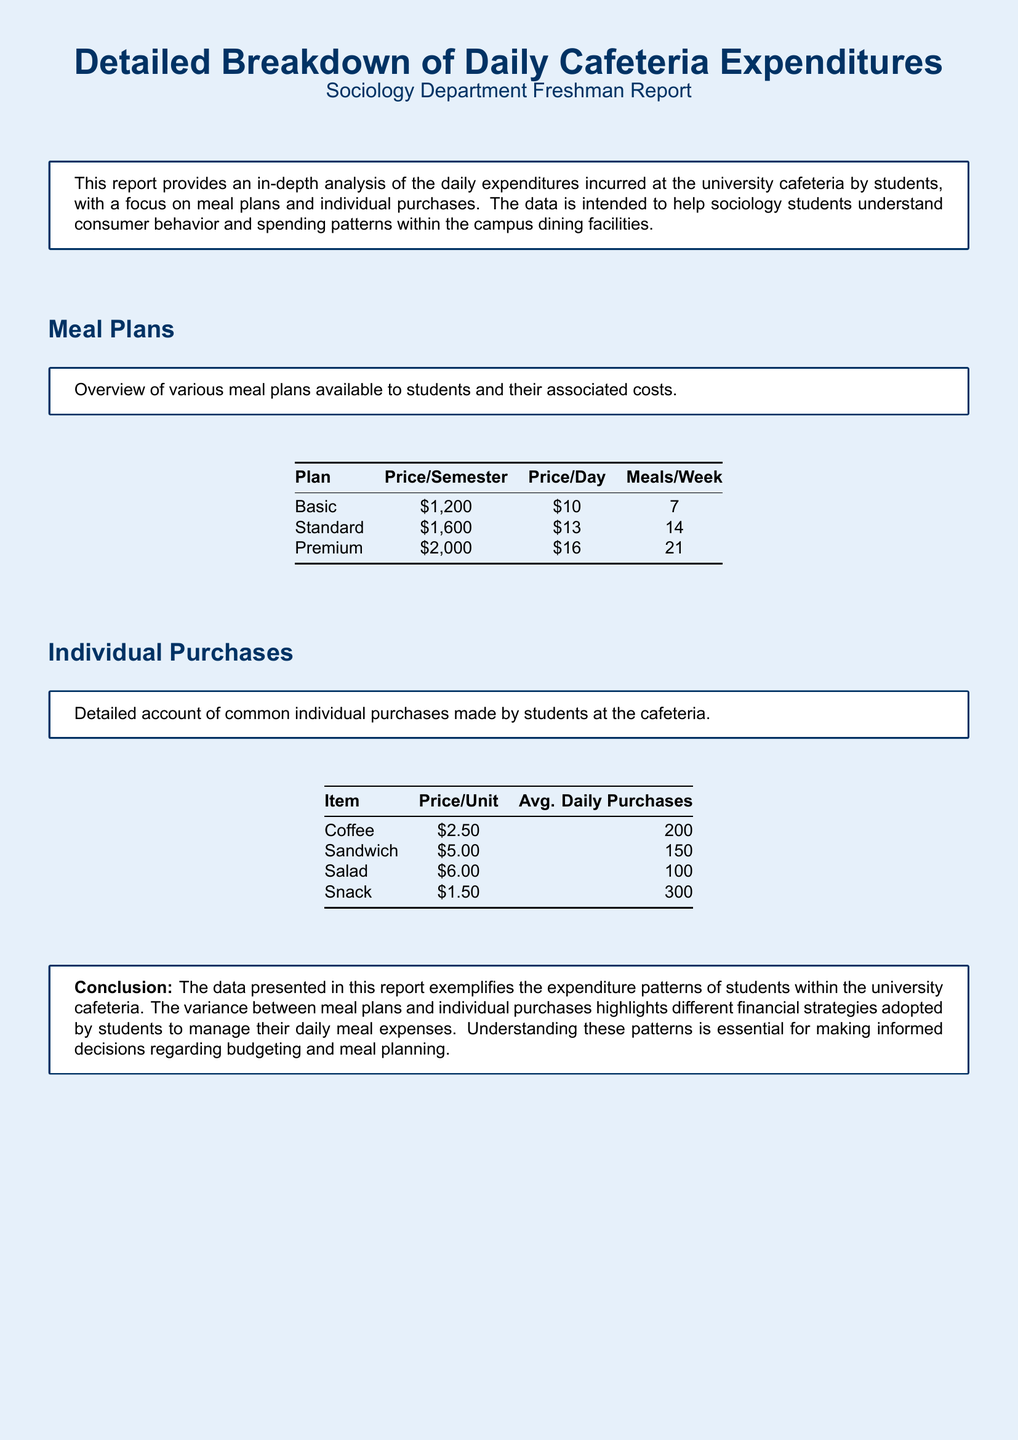What is the price of the Basic meal plan? The Basic meal plan costs $1,200 per semester, as stated in the document.
Answer: $1,200 What is the average daily purchases of sandwiches? The document states that the average daily purchases of sandwiches is 150.
Answer: 150 What is the price per unit of coffee? Coffee is priced at $2.50 per unit, which is detailed in the individual purchases section.
Answer: $2.50 How many meals per week does the Premium plan offer? The Premium meal plan offers 21 meals per week, as outlined in the table.
Answer: 21 What is the price per day for the Standard meal plan? The Standard meal plan costs $13 per day, according to the meal plans section.
Answer: $13 Which individual item has the highest average daily purchases? The document indicates that snacks have the highest average daily purchases at 300.
Answer: Snack What is the conclusion of the report? The conclusion summarizes expenditure patterns, emphasizing the financial strategies students adopt, per the text in the document.
Answer: The data presented in this report exemplifies the expenditure patterns of students within the university cafeteria What are the associated costs for the Premium meal plan? The Premium meal plan's associated costs include $2,000 per semester and $16 per day.
Answer: $2,000, $16 How much does a salad cost per unit? The document notes that a salad costs $6.00 per unit.
Answer: $6.00 